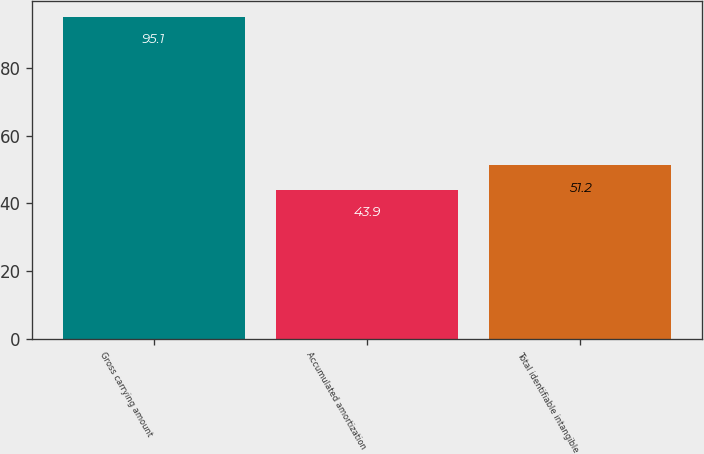Convert chart. <chart><loc_0><loc_0><loc_500><loc_500><bar_chart><fcel>Gross carrying amount<fcel>Accumulated amortization<fcel>Total identifiable intangible<nl><fcel>95.1<fcel>43.9<fcel>51.2<nl></chart> 